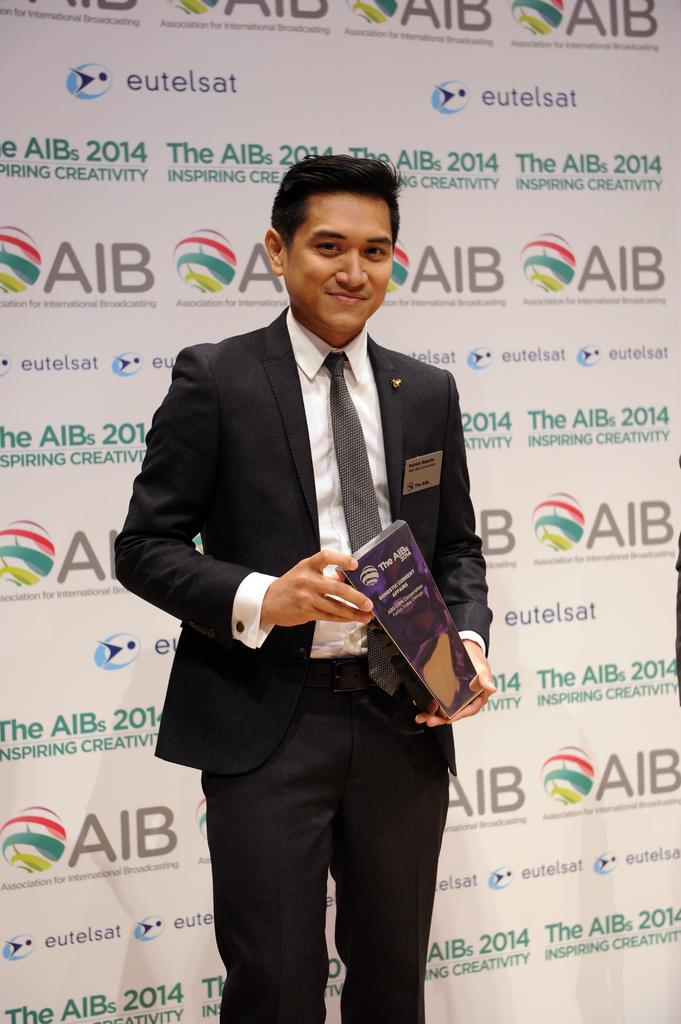What is the person in the image doing? The person is standing in the image and smiling. What is the person holding in the image? The person is holding an object in the image. What can be seen in the background of the image? There is a hoarding in the background of the image. What is written on the hoarding? There is text on the hoarding. What type of ink is being used to write on the hoarding in the image? There is no information about the type of ink being used on the hoarding in the image. 